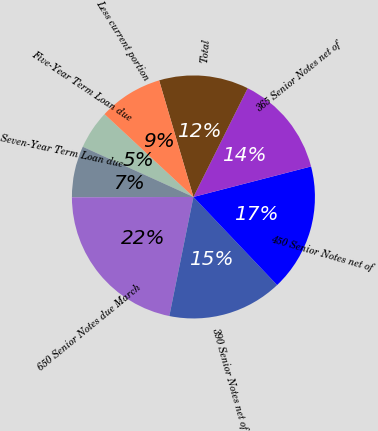<chart> <loc_0><loc_0><loc_500><loc_500><pie_chart><fcel>Five-Year Term Loan due<fcel>Seven-Year Term Loan due<fcel>650 Senior Notes due March<fcel>390 Senior Notes net of<fcel>450 Senior Notes net of<fcel>365 Senior Notes net of<fcel>Total<fcel>Less current portion<nl><fcel>5.16%<fcel>6.83%<fcel>21.77%<fcel>15.27%<fcel>16.95%<fcel>13.6%<fcel>11.92%<fcel>8.51%<nl></chart> 